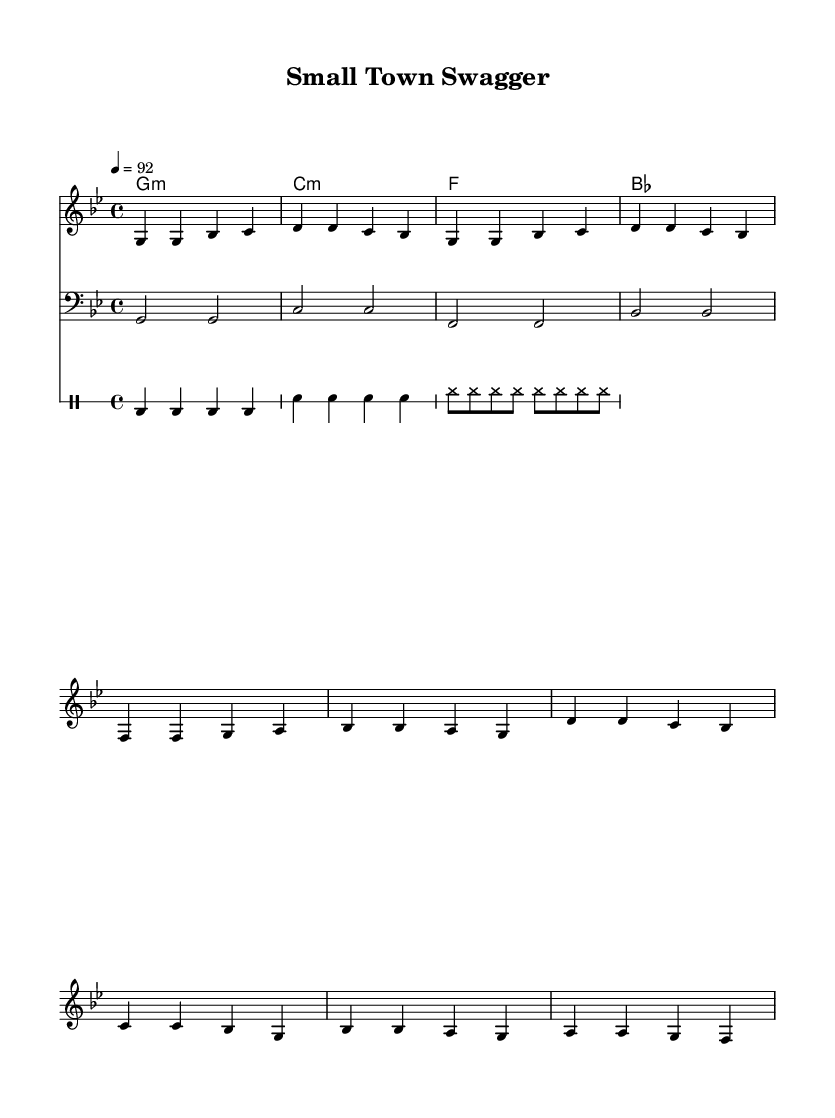What is the key signature of this music? The key signature indicated in the sheet music is G minor, which has two flats (B flat and E flat).
Answer: G minor What is the time signature of this piece? The time signature shown in the sheet music is 4/4, meaning there are four beats in each measure and a quarter note receives one beat.
Answer: 4/4 What is the tempo marking for this music? The tempo marking provided in the music is 92 beats per minute, indicated by the notation "4 = 92."
Answer: 92 How many measures are there in the verse section? Counting the measures of the section labeled "Verse," there are four measures in total, marked with specific melodic and harmonic patterns.
Answer: 4 What chord is played on the first beat of the chorus? The chord on the first beat of the chorus is D minor, as indicated by the chord layout specified at the beginning of that section.
Answer: D minor Which instrument plays the bass line in this composition? The bass line is played by the bass staff, which is specifically notated to indicate lower register pitches, distinct from the treble staff used for melody.
Answer: Bass What characteristic makes this piece a Hip Hop anthem? The piece incorporates elements common in Hip Hop, such as a strong backbeat from the drums, repetitive melodic hooks, and a focus on community themes represented in the lyrics.
Answer: Community themes 